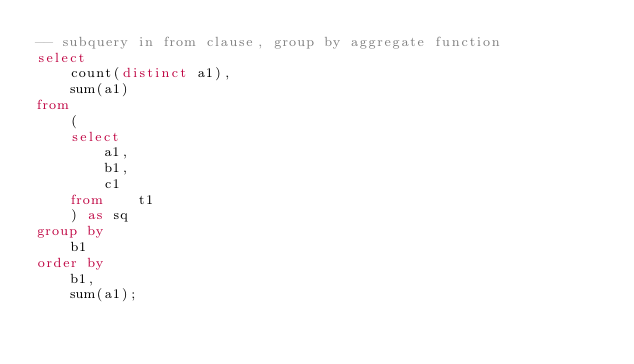<code> <loc_0><loc_0><loc_500><loc_500><_SQL_>-- subquery in from clause, group by aggregate function
select 
	count(distinct a1), 
	sum(a1) 
from 
	(
	select 
		a1, 
		b1, 
		c1 
	from 	t1
	) as sq
group by 
	b1 
order by 
	b1,
	sum(a1);
</code> 